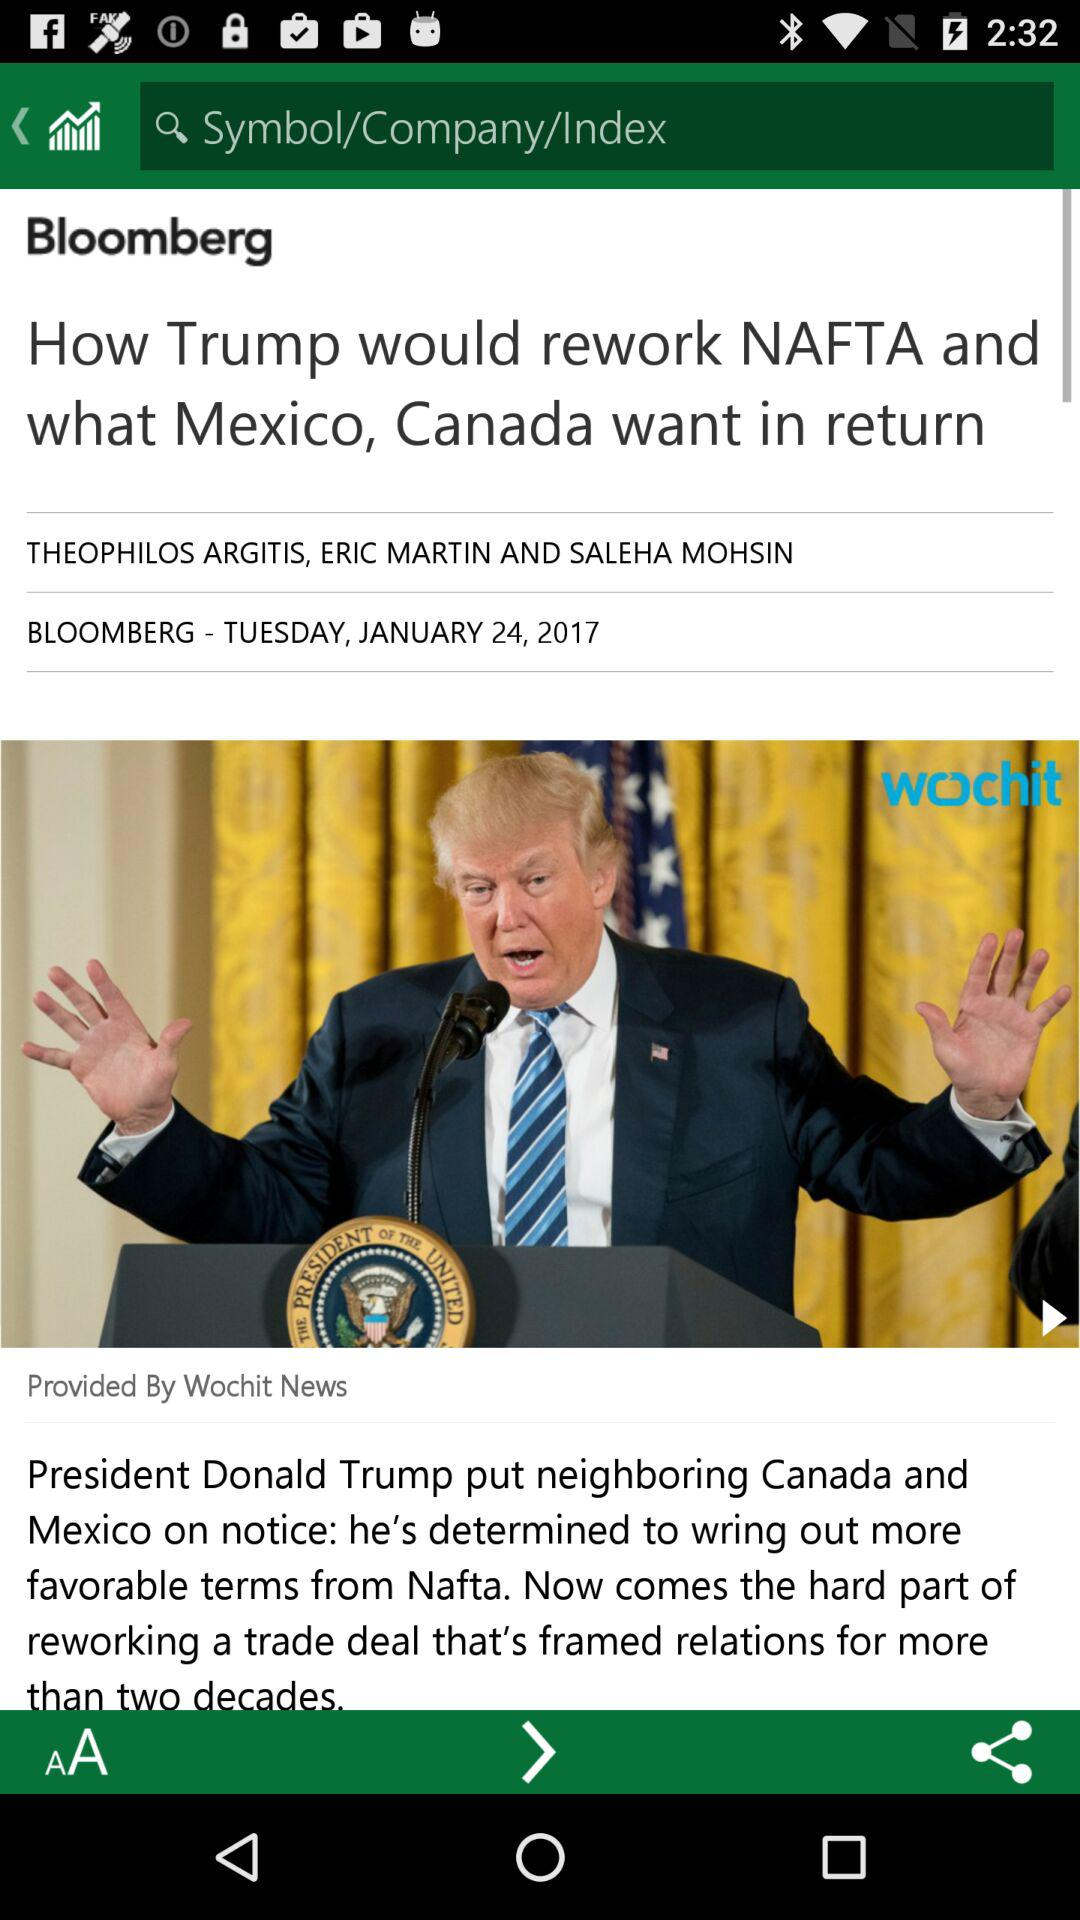What is the date of the article? The date is Tuesday, January 24, 2017. 